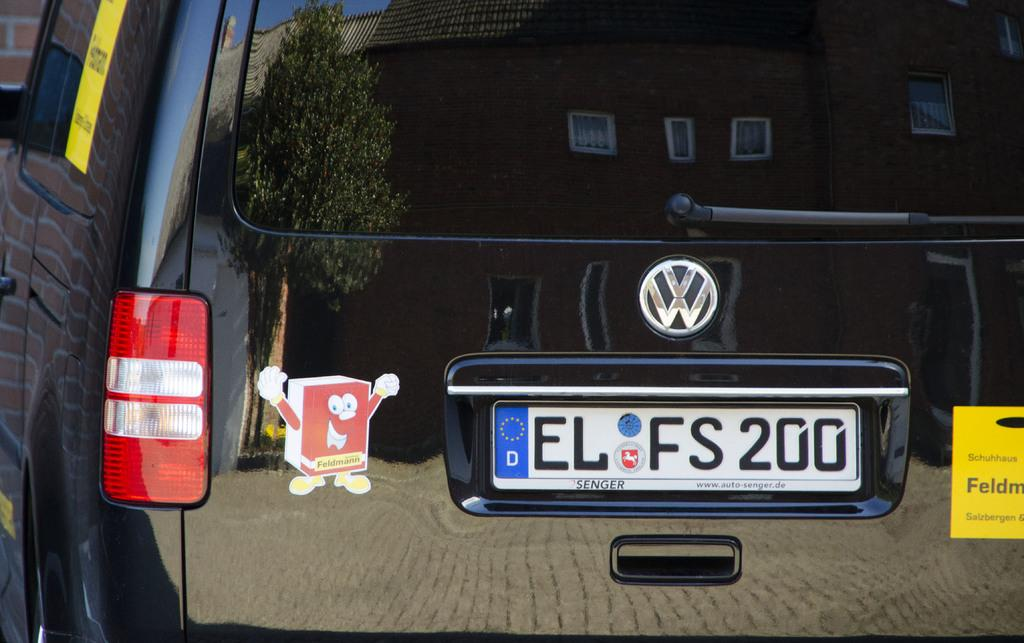Provide a one-sentence caption for the provided image. black vw car with the license place elfs200. 